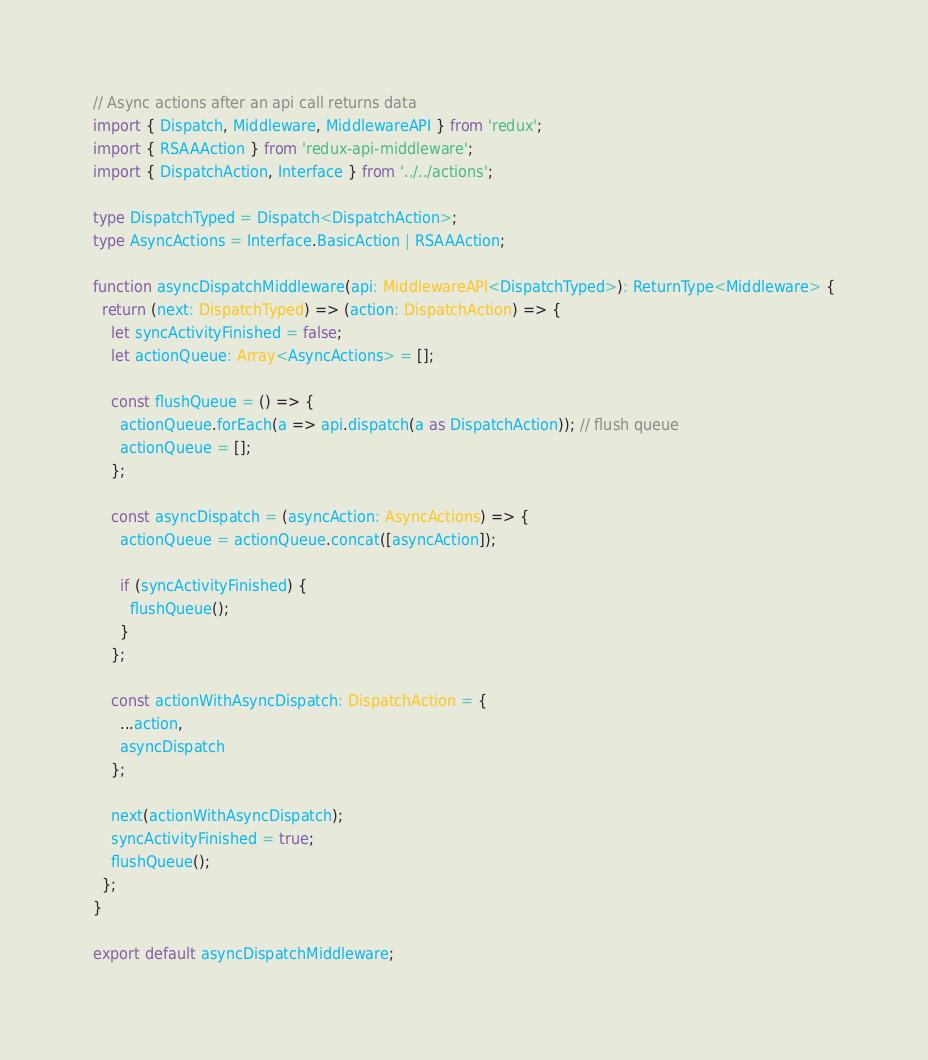Convert code to text. <code><loc_0><loc_0><loc_500><loc_500><_TypeScript_>// Async actions after an api call returns data
import { Dispatch, Middleware, MiddlewareAPI } from 'redux';
import { RSAAAction } from 'redux-api-middleware';
import { DispatchAction, Interface } from '../../actions';

type DispatchTyped = Dispatch<DispatchAction>;
type AsyncActions = Interface.BasicAction | RSAAAction;

function asyncDispatchMiddleware(api: MiddlewareAPI<DispatchTyped>): ReturnType<Middleware> {
  return (next: DispatchTyped) => (action: DispatchAction) => {
    let syncActivityFinished = false;
    let actionQueue: Array<AsyncActions> = [];

    const flushQueue = () => {
      actionQueue.forEach(a => api.dispatch(a as DispatchAction)); // flush queue
      actionQueue = [];
    };

    const asyncDispatch = (asyncAction: AsyncActions) => {
      actionQueue = actionQueue.concat([asyncAction]);

      if (syncActivityFinished) {
        flushQueue();
      }
    };

    const actionWithAsyncDispatch: DispatchAction = {
      ...action,
      asyncDispatch
    };

    next(actionWithAsyncDispatch);
    syncActivityFinished = true;
    flushQueue();
  };
}

export default asyncDispatchMiddleware;</code> 